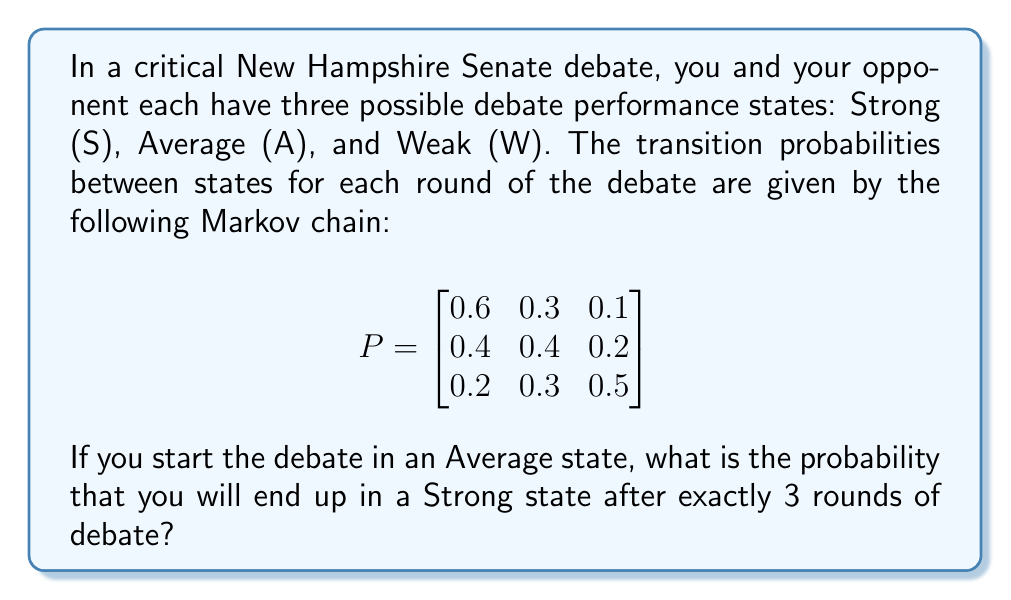Solve this math problem. To solve this problem, we need to use the Markov chain transition matrix and calculate the probability of ending up in a Strong state after 3 transitions, starting from an Average state.

Step 1: Identify the initial state vector.
Since we start in an Average state, our initial state vector is:
$$ v_0 = \begin{bmatrix} 0 & 1 & 0 \end{bmatrix} $$

Step 2: Calculate the state after 3 transitions.
We need to multiply the initial state vector by the transition matrix raised to the power of 3:
$$ v_3 = v_0 \cdot P^3 $$

Step 3: Calculate $P^3$ using matrix multiplication.
$$ P^2 = P \cdot P = \begin{bmatrix}
0.52 & 0.33 & 0.15 \\
0.44 & 0.36 & 0.20 \\
0.34 & 0.33 & 0.33
\end{bmatrix} $$

$$ P^3 = P^2 \cdot P = \begin{bmatrix}
0.484 & 0.333 & 0.183 \\
0.452 & 0.342 & 0.206 \\
0.404 & 0.333 & 0.263
\end{bmatrix} $$

Step 4: Multiply the initial state vector by $P^3$.
$$ v_3 = \begin{bmatrix} 0 & 1 & 0 \end{bmatrix} \cdot \begin{bmatrix}
0.484 & 0.333 & 0.183 \\
0.452 & 0.342 & 0.206 \\
0.404 & 0.333 & 0.263
\end{bmatrix} $$

$$ v_3 = \begin{bmatrix} 0.452 & 0.342 & 0.206 \end{bmatrix} $$

Step 5: The probability of ending up in a Strong state (first element of $v_3$) is 0.452 or 45.2%.
Answer: 0.452 